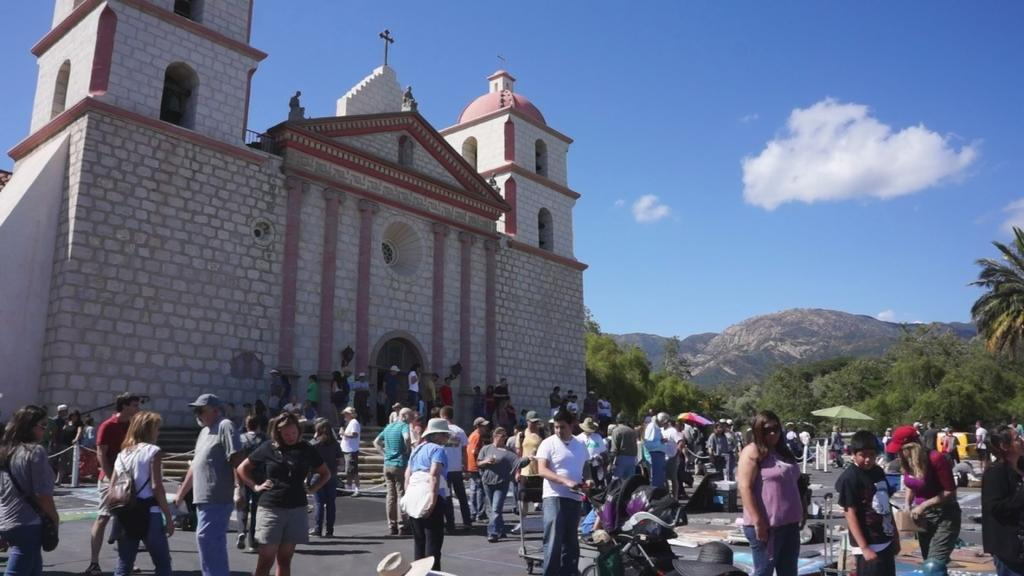How many people are in the group visible in the image? There is a group of people standing in the image, but the exact number cannot be determined from the provided facts. What is located behind the group of people? There is a building and a group of trees visible behind the people. What is the most distant feature visible in the image? The mountains are visible in the background. What is visible at the top of the image? The sky is visible at the top of the image. What color is the ink used to write on the banana in the image? There is no banana or ink present in the image. How does the way the people are standing affect the view of the mountains? The way the people are standing does not affect the view of the mountains, as they are located in the background and are not obstructed by the group of people. 